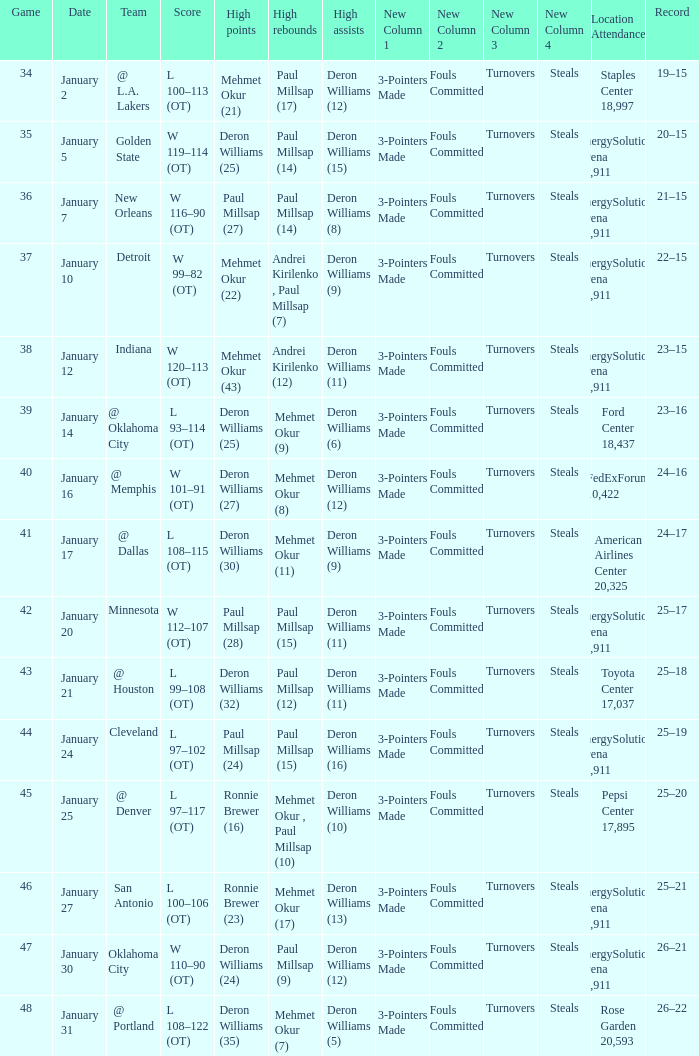Who had the high rebounds on January 24? Paul Millsap (15). 